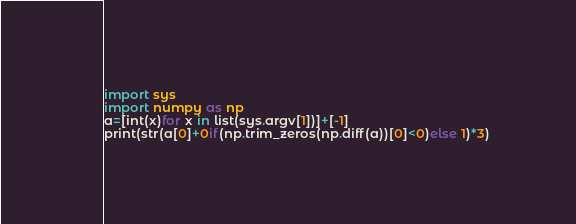<code> <loc_0><loc_0><loc_500><loc_500><_Python_>import sys
import numpy as np
a=[int(x)for x in list(sys.argv[1])]+[-1]
print(str(a[0]+0if(np.trim_zeros(np.diff(a))[0]<0)else 1)*3)
</code> 